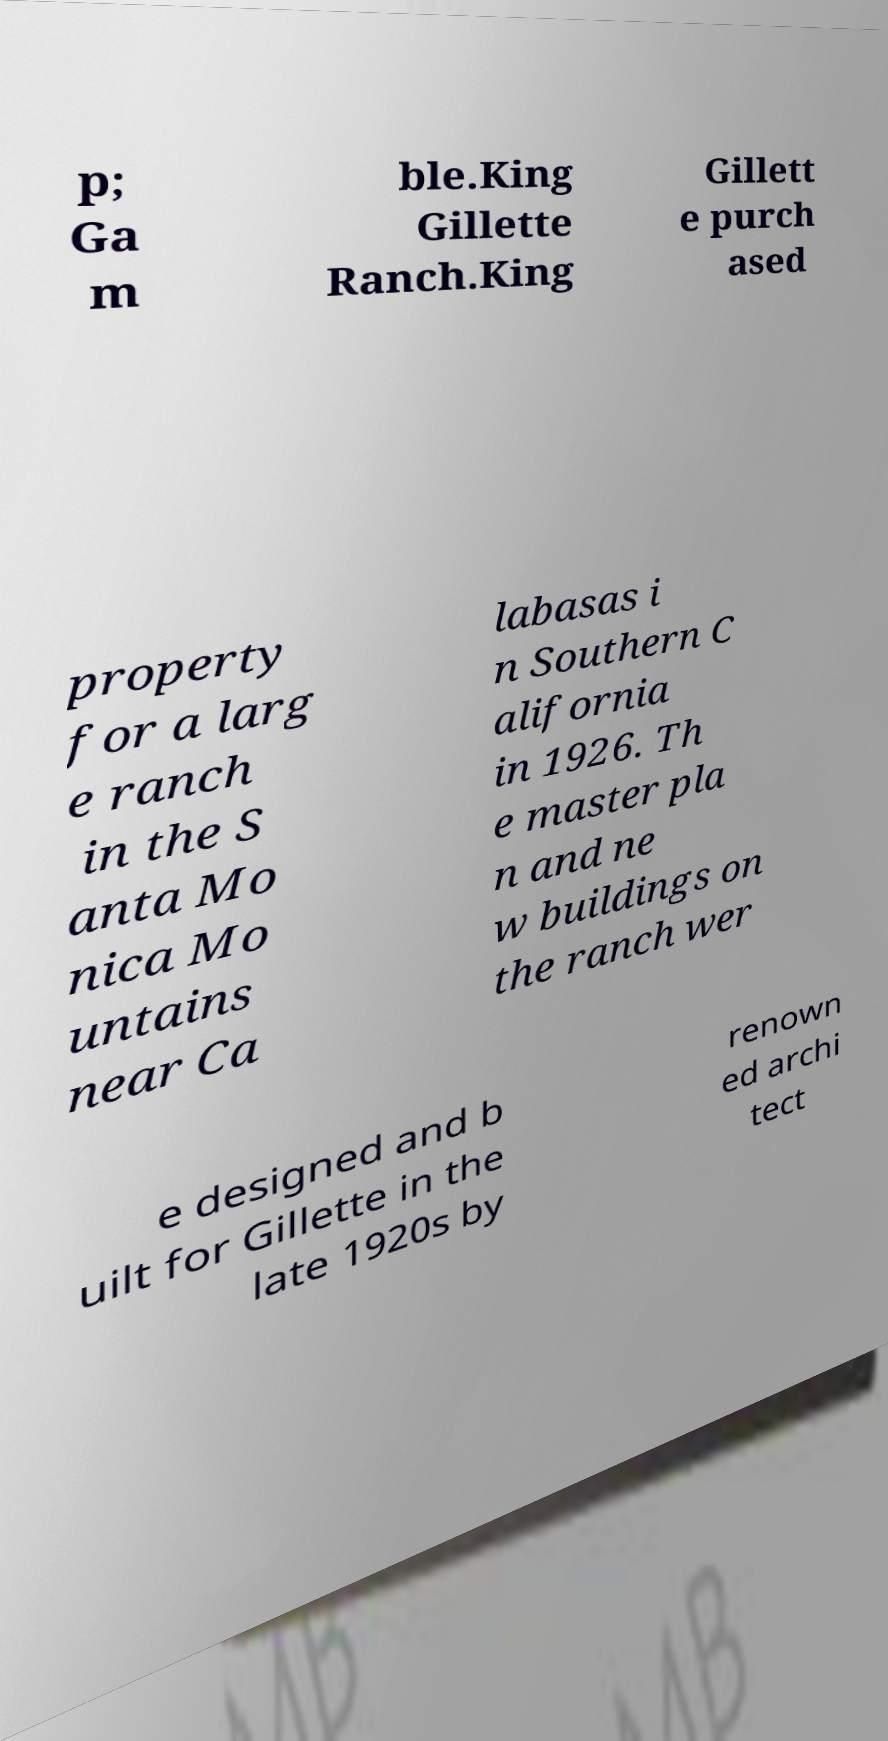For documentation purposes, I need the text within this image transcribed. Could you provide that? p; Ga m ble.King Gillette Ranch.King Gillett e purch ased property for a larg e ranch in the S anta Mo nica Mo untains near Ca labasas i n Southern C alifornia in 1926. Th e master pla n and ne w buildings on the ranch wer e designed and b uilt for Gillette in the late 1920s by renown ed archi tect 